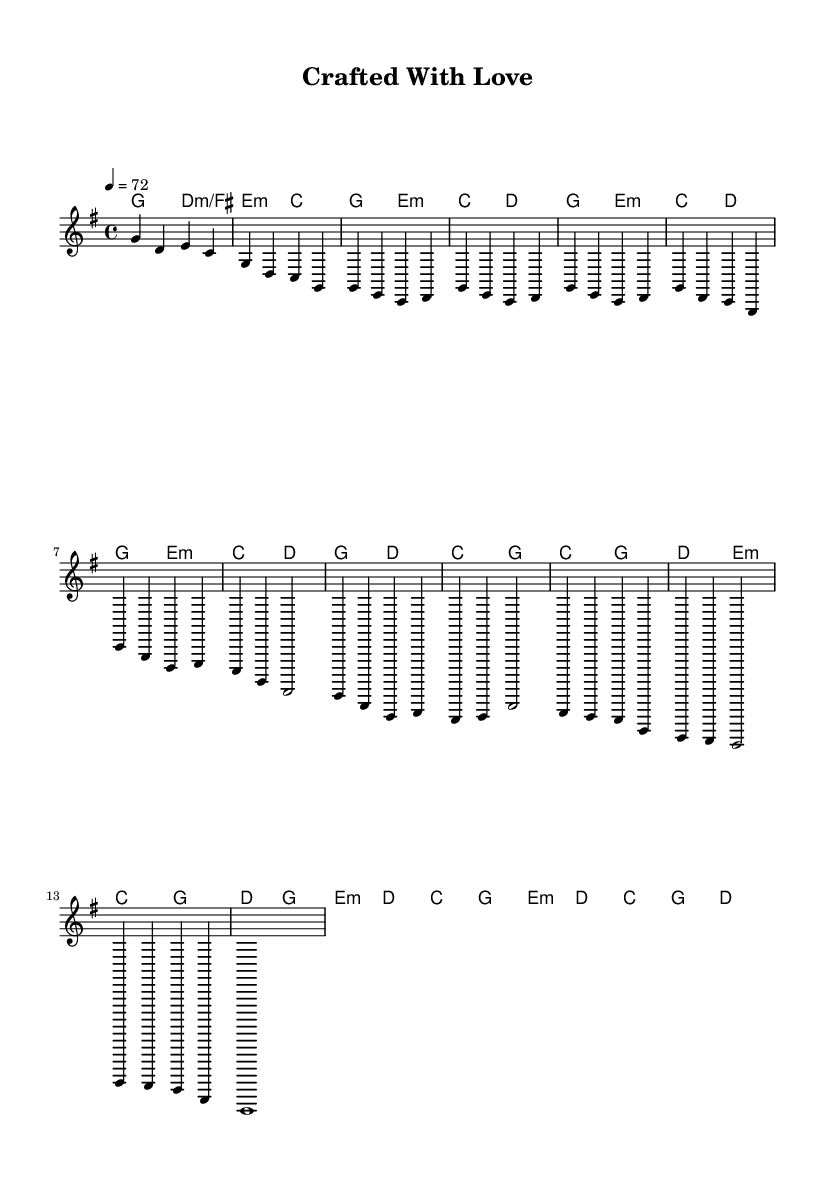What is the key signature of this music? The key signature is G major, which includes one sharp (F#). This can be identified by looking at the key signature indication at the beginning of the staff.
Answer: G major What is the time signature of the piece? The time signature is 4/4, as indicated at the beginning of the score by the fraction, which shows four beats per measure with a quarter note receiving one beat.
Answer: 4/4 What is the tempo marking for the music? The tempo marking indicates a speed of 72 beats per minute, shown by the "tempo 4 = 72" indication, which specifies the number of beats in a minute.
Answer: 72 How many measures are in the chorus section? The chorus section contains four measures, as counted from the start of the chorus notation to the end.
Answer: 4 In which section does the melody first introduce the note E? The note E first appears in Verse 1 of the melody, where it is played in several measures after the introductory section.
Answer: Verse 1 What are the two primary chord types used in the chorus? The primary chord types used in the chorus are C major and G major, which are indicated in the chord changes for the chorus section.
Answer: C major, G major How does the bridge section contrast with the verse sections musically? The bridge section uses a different rhythmic and melodic pattern and features the chords E minor and D major, creating a dynamic contrast when compared to the repetitive nature of the verses.
Answer: Contrast in rhythm and chords 